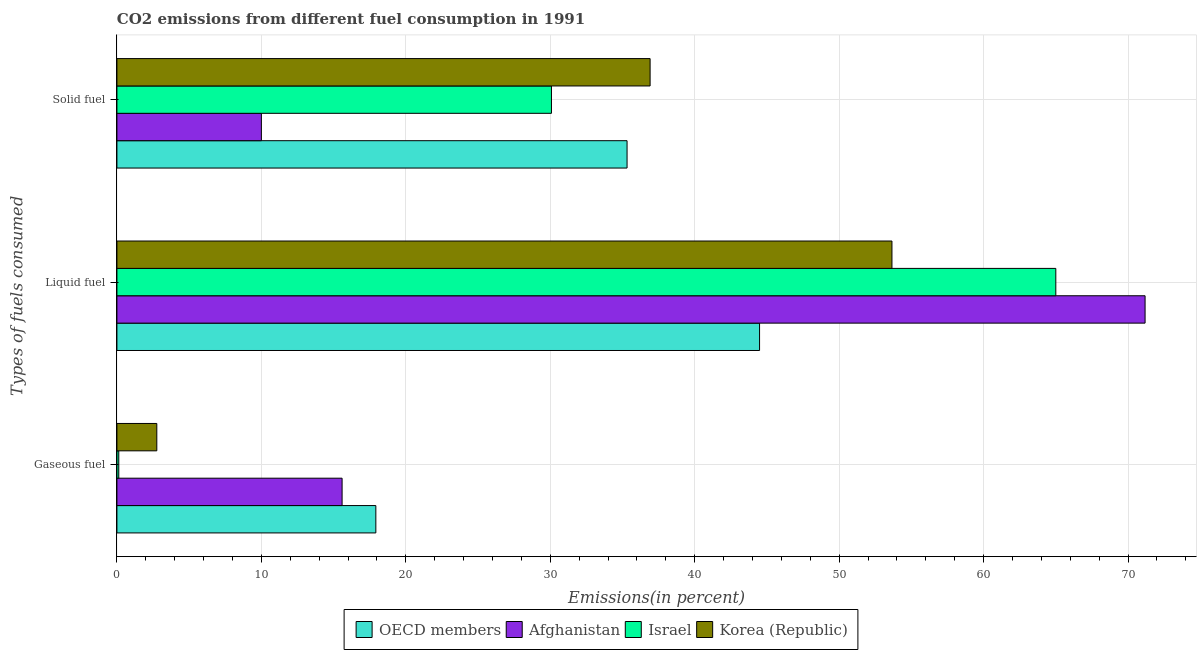How many different coloured bars are there?
Keep it short and to the point. 4. Are the number of bars on each tick of the Y-axis equal?
Make the answer very short. Yes. What is the label of the 2nd group of bars from the top?
Your answer should be compact. Liquid fuel. What is the percentage of liquid fuel emission in Afghanistan?
Ensure brevity in your answer.  71.18. Across all countries, what is the maximum percentage of gaseous fuel emission?
Keep it short and to the point. 17.92. Across all countries, what is the minimum percentage of liquid fuel emission?
Your response must be concise. 44.49. In which country was the percentage of solid fuel emission minimum?
Give a very brief answer. Afghanistan. What is the total percentage of gaseous fuel emission in the graph?
Keep it short and to the point. 36.4. What is the difference between the percentage of gaseous fuel emission in OECD members and that in Afghanistan?
Offer a terse response. 2.34. What is the difference between the percentage of liquid fuel emission in OECD members and the percentage of solid fuel emission in Israel?
Make the answer very short. 14.41. What is the average percentage of liquid fuel emission per country?
Give a very brief answer. 58.58. What is the difference between the percentage of liquid fuel emission and percentage of solid fuel emission in Israel?
Ensure brevity in your answer.  34.91. In how many countries, is the percentage of gaseous fuel emission greater than 60 %?
Offer a very short reply. 0. What is the ratio of the percentage of liquid fuel emission in Afghanistan to that in OECD members?
Give a very brief answer. 1.6. Is the difference between the percentage of gaseous fuel emission in OECD members and Israel greater than the difference between the percentage of liquid fuel emission in OECD members and Israel?
Offer a terse response. Yes. What is the difference between the highest and the second highest percentage of gaseous fuel emission?
Offer a terse response. 2.34. What is the difference between the highest and the lowest percentage of solid fuel emission?
Offer a terse response. 26.91. Is the sum of the percentage of solid fuel emission in Israel and OECD members greater than the maximum percentage of liquid fuel emission across all countries?
Offer a terse response. No. What does the 4th bar from the bottom in Gaseous fuel represents?
Your answer should be compact. Korea (Republic). Is it the case that in every country, the sum of the percentage of gaseous fuel emission and percentage of liquid fuel emission is greater than the percentage of solid fuel emission?
Your response must be concise. Yes. Are all the bars in the graph horizontal?
Make the answer very short. Yes. Are the values on the major ticks of X-axis written in scientific E-notation?
Your response must be concise. No. Does the graph contain any zero values?
Ensure brevity in your answer.  No. How many legend labels are there?
Provide a short and direct response. 4. What is the title of the graph?
Provide a succinct answer. CO2 emissions from different fuel consumption in 1991. Does "Trinidad and Tobago" appear as one of the legend labels in the graph?
Keep it short and to the point. No. What is the label or title of the X-axis?
Make the answer very short. Emissions(in percent). What is the label or title of the Y-axis?
Give a very brief answer. Types of fuels consumed. What is the Emissions(in percent) in OECD members in Gaseous fuel?
Offer a very short reply. 17.92. What is the Emissions(in percent) of Afghanistan in Gaseous fuel?
Your answer should be compact. 15.59. What is the Emissions(in percent) in Israel in Gaseous fuel?
Your answer should be compact. 0.13. What is the Emissions(in percent) of Korea (Republic) in Gaseous fuel?
Offer a very short reply. 2.76. What is the Emissions(in percent) of OECD members in Liquid fuel?
Give a very brief answer. 44.49. What is the Emissions(in percent) of Afghanistan in Liquid fuel?
Provide a short and direct response. 71.18. What is the Emissions(in percent) of Israel in Liquid fuel?
Ensure brevity in your answer.  65. What is the Emissions(in percent) of Korea (Republic) in Liquid fuel?
Offer a very short reply. 53.65. What is the Emissions(in percent) in OECD members in Solid fuel?
Your answer should be very brief. 35.32. What is the Emissions(in percent) of Israel in Solid fuel?
Give a very brief answer. 30.08. What is the Emissions(in percent) in Korea (Republic) in Solid fuel?
Ensure brevity in your answer.  36.91. Across all Types of fuels consumed, what is the maximum Emissions(in percent) in OECD members?
Offer a terse response. 44.49. Across all Types of fuels consumed, what is the maximum Emissions(in percent) of Afghanistan?
Keep it short and to the point. 71.18. Across all Types of fuels consumed, what is the maximum Emissions(in percent) in Israel?
Provide a succinct answer. 65. Across all Types of fuels consumed, what is the maximum Emissions(in percent) of Korea (Republic)?
Offer a very short reply. 53.65. Across all Types of fuels consumed, what is the minimum Emissions(in percent) of OECD members?
Offer a very short reply. 17.92. Across all Types of fuels consumed, what is the minimum Emissions(in percent) in Israel?
Provide a succinct answer. 0.13. Across all Types of fuels consumed, what is the minimum Emissions(in percent) in Korea (Republic)?
Make the answer very short. 2.76. What is the total Emissions(in percent) in OECD members in the graph?
Your response must be concise. 97.73. What is the total Emissions(in percent) of Afghanistan in the graph?
Your answer should be compact. 96.76. What is the total Emissions(in percent) of Israel in the graph?
Provide a succinct answer. 95.21. What is the total Emissions(in percent) in Korea (Republic) in the graph?
Offer a terse response. 93.32. What is the difference between the Emissions(in percent) in OECD members in Gaseous fuel and that in Liquid fuel?
Give a very brief answer. -26.56. What is the difference between the Emissions(in percent) of Afghanistan in Gaseous fuel and that in Liquid fuel?
Give a very brief answer. -55.59. What is the difference between the Emissions(in percent) in Israel in Gaseous fuel and that in Liquid fuel?
Provide a short and direct response. -64.87. What is the difference between the Emissions(in percent) of Korea (Republic) in Gaseous fuel and that in Liquid fuel?
Your answer should be compact. -50.89. What is the difference between the Emissions(in percent) in OECD members in Gaseous fuel and that in Solid fuel?
Your answer should be very brief. -17.39. What is the difference between the Emissions(in percent) in Afghanistan in Gaseous fuel and that in Solid fuel?
Keep it short and to the point. 5.59. What is the difference between the Emissions(in percent) in Israel in Gaseous fuel and that in Solid fuel?
Provide a short and direct response. -29.95. What is the difference between the Emissions(in percent) in Korea (Republic) in Gaseous fuel and that in Solid fuel?
Offer a terse response. -34.15. What is the difference between the Emissions(in percent) of OECD members in Liquid fuel and that in Solid fuel?
Your answer should be very brief. 9.17. What is the difference between the Emissions(in percent) of Afghanistan in Liquid fuel and that in Solid fuel?
Offer a terse response. 61.18. What is the difference between the Emissions(in percent) of Israel in Liquid fuel and that in Solid fuel?
Give a very brief answer. 34.91. What is the difference between the Emissions(in percent) in Korea (Republic) in Liquid fuel and that in Solid fuel?
Keep it short and to the point. 16.74. What is the difference between the Emissions(in percent) in OECD members in Gaseous fuel and the Emissions(in percent) in Afghanistan in Liquid fuel?
Your answer should be compact. -53.25. What is the difference between the Emissions(in percent) in OECD members in Gaseous fuel and the Emissions(in percent) in Israel in Liquid fuel?
Provide a succinct answer. -47.07. What is the difference between the Emissions(in percent) of OECD members in Gaseous fuel and the Emissions(in percent) of Korea (Republic) in Liquid fuel?
Offer a very short reply. -35.73. What is the difference between the Emissions(in percent) of Afghanistan in Gaseous fuel and the Emissions(in percent) of Israel in Liquid fuel?
Provide a succinct answer. -49.41. What is the difference between the Emissions(in percent) of Afghanistan in Gaseous fuel and the Emissions(in percent) of Korea (Republic) in Liquid fuel?
Keep it short and to the point. -38.06. What is the difference between the Emissions(in percent) of Israel in Gaseous fuel and the Emissions(in percent) of Korea (Republic) in Liquid fuel?
Provide a succinct answer. -53.52. What is the difference between the Emissions(in percent) of OECD members in Gaseous fuel and the Emissions(in percent) of Afghanistan in Solid fuel?
Give a very brief answer. 7.92. What is the difference between the Emissions(in percent) of OECD members in Gaseous fuel and the Emissions(in percent) of Israel in Solid fuel?
Your answer should be very brief. -12.16. What is the difference between the Emissions(in percent) in OECD members in Gaseous fuel and the Emissions(in percent) in Korea (Republic) in Solid fuel?
Your answer should be very brief. -18.99. What is the difference between the Emissions(in percent) in Afghanistan in Gaseous fuel and the Emissions(in percent) in Israel in Solid fuel?
Offer a terse response. -14.49. What is the difference between the Emissions(in percent) of Afghanistan in Gaseous fuel and the Emissions(in percent) of Korea (Republic) in Solid fuel?
Your response must be concise. -21.32. What is the difference between the Emissions(in percent) of Israel in Gaseous fuel and the Emissions(in percent) of Korea (Republic) in Solid fuel?
Provide a succinct answer. -36.78. What is the difference between the Emissions(in percent) in OECD members in Liquid fuel and the Emissions(in percent) in Afghanistan in Solid fuel?
Your response must be concise. 34.49. What is the difference between the Emissions(in percent) in OECD members in Liquid fuel and the Emissions(in percent) in Israel in Solid fuel?
Your answer should be very brief. 14.41. What is the difference between the Emissions(in percent) of OECD members in Liquid fuel and the Emissions(in percent) of Korea (Republic) in Solid fuel?
Provide a short and direct response. 7.58. What is the difference between the Emissions(in percent) in Afghanistan in Liquid fuel and the Emissions(in percent) in Israel in Solid fuel?
Provide a succinct answer. 41.1. What is the difference between the Emissions(in percent) in Afghanistan in Liquid fuel and the Emissions(in percent) in Korea (Republic) in Solid fuel?
Make the answer very short. 34.27. What is the difference between the Emissions(in percent) in Israel in Liquid fuel and the Emissions(in percent) in Korea (Republic) in Solid fuel?
Offer a terse response. 28.09. What is the average Emissions(in percent) of OECD members per Types of fuels consumed?
Provide a short and direct response. 32.58. What is the average Emissions(in percent) in Afghanistan per Types of fuels consumed?
Provide a short and direct response. 32.25. What is the average Emissions(in percent) of Israel per Types of fuels consumed?
Keep it short and to the point. 31.74. What is the average Emissions(in percent) of Korea (Republic) per Types of fuels consumed?
Keep it short and to the point. 31.11. What is the difference between the Emissions(in percent) in OECD members and Emissions(in percent) in Afghanistan in Gaseous fuel?
Provide a short and direct response. 2.34. What is the difference between the Emissions(in percent) in OECD members and Emissions(in percent) in Israel in Gaseous fuel?
Offer a very short reply. 17.8. What is the difference between the Emissions(in percent) of OECD members and Emissions(in percent) of Korea (Republic) in Gaseous fuel?
Offer a terse response. 15.16. What is the difference between the Emissions(in percent) of Afghanistan and Emissions(in percent) of Israel in Gaseous fuel?
Ensure brevity in your answer.  15.46. What is the difference between the Emissions(in percent) in Afghanistan and Emissions(in percent) in Korea (Republic) in Gaseous fuel?
Give a very brief answer. 12.83. What is the difference between the Emissions(in percent) of Israel and Emissions(in percent) of Korea (Republic) in Gaseous fuel?
Give a very brief answer. -2.63. What is the difference between the Emissions(in percent) in OECD members and Emissions(in percent) in Afghanistan in Liquid fuel?
Offer a terse response. -26.69. What is the difference between the Emissions(in percent) in OECD members and Emissions(in percent) in Israel in Liquid fuel?
Provide a short and direct response. -20.51. What is the difference between the Emissions(in percent) in OECD members and Emissions(in percent) in Korea (Republic) in Liquid fuel?
Offer a terse response. -9.16. What is the difference between the Emissions(in percent) in Afghanistan and Emissions(in percent) in Israel in Liquid fuel?
Ensure brevity in your answer.  6.18. What is the difference between the Emissions(in percent) of Afghanistan and Emissions(in percent) of Korea (Republic) in Liquid fuel?
Ensure brevity in your answer.  17.52. What is the difference between the Emissions(in percent) of Israel and Emissions(in percent) of Korea (Republic) in Liquid fuel?
Keep it short and to the point. 11.34. What is the difference between the Emissions(in percent) of OECD members and Emissions(in percent) of Afghanistan in Solid fuel?
Give a very brief answer. 25.32. What is the difference between the Emissions(in percent) of OECD members and Emissions(in percent) of Israel in Solid fuel?
Provide a succinct answer. 5.23. What is the difference between the Emissions(in percent) in OECD members and Emissions(in percent) in Korea (Republic) in Solid fuel?
Provide a succinct answer. -1.6. What is the difference between the Emissions(in percent) in Afghanistan and Emissions(in percent) in Israel in Solid fuel?
Provide a succinct answer. -20.08. What is the difference between the Emissions(in percent) in Afghanistan and Emissions(in percent) in Korea (Republic) in Solid fuel?
Offer a very short reply. -26.91. What is the difference between the Emissions(in percent) of Israel and Emissions(in percent) of Korea (Republic) in Solid fuel?
Keep it short and to the point. -6.83. What is the ratio of the Emissions(in percent) in OECD members in Gaseous fuel to that in Liquid fuel?
Your answer should be very brief. 0.4. What is the ratio of the Emissions(in percent) of Afghanistan in Gaseous fuel to that in Liquid fuel?
Keep it short and to the point. 0.22. What is the ratio of the Emissions(in percent) in Israel in Gaseous fuel to that in Liquid fuel?
Your response must be concise. 0. What is the ratio of the Emissions(in percent) of Korea (Republic) in Gaseous fuel to that in Liquid fuel?
Provide a short and direct response. 0.05. What is the ratio of the Emissions(in percent) of OECD members in Gaseous fuel to that in Solid fuel?
Offer a terse response. 0.51. What is the ratio of the Emissions(in percent) in Afghanistan in Gaseous fuel to that in Solid fuel?
Make the answer very short. 1.56. What is the ratio of the Emissions(in percent) in Israel in Gaseous fuel to that in Solid fuel?
Your answer should be very brief. 0. What is the ratio of the Emissions(in percent) in Korea (Republic) in Gaseous fuel to that in Solid fuel?
Offer a very short reply. 0.07. What is the ratio of the Emissions(in percent) of OECD members in Liquid fuel to that in Solid fuel?
Give a very brief answer. 1.26. What is the ratio of the Emissions(in percent) in Afghanistan in Liquid fuel to that in Solid fuel?
Offer a very short reply. 7.12. What is the ratio of the Emissions(in percent) of Israel in Liquid fuel to that in Solid fuel?
Give a very brief answer. 2.16. What is the ratio of the Emissions(in percent) in Korea (Republic) in Liquid fuel to that in Solid fuel?
Offer a terse response. 1.45. What is the difference between the highest and the second highest Emissions(in percent) of OECD members?
Provide a succinct answer. 9.17. What is the difference between the highest and the second highest Emissions(in percent) of Afghanistan?
Your response must be concise. 55.59. What is the difference between the highest and the second highest Emissions(in percent) in Israel?
Keep it short and to the point. 34.91. What is the difference between the highest and the second highest Emissions(in percent) of Korea (Republic)?
Ensure brevity in your answer.  16.74. What is the difference between the highest and the lowest Emissions(in percent) of OECD members?
Offer a terse response. 26.56. What is the difference between the highest and the lowest Emissions(in percent) of Afghanistan?
Give a very brief answer. 61.18. What is the difference between the highest and the lowest Emissions(in percent) in Israel?
Keep it short and to the point. 64.87. What is the difference between the highest and the lowest Emissions(in percent) of Korea (Republic)?
Keep it short and to the point. 50.89. 